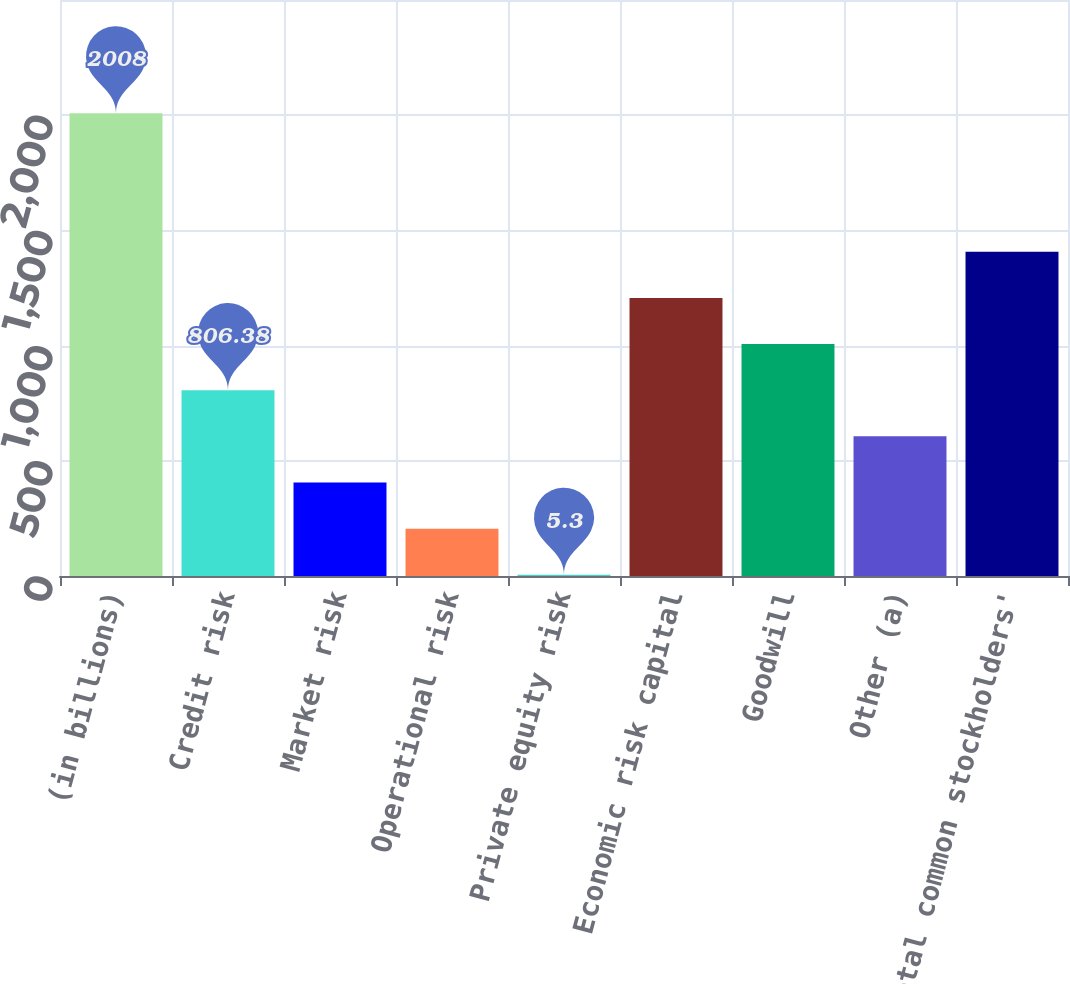Convert chart to OTSL. <chart><loc_0><loc_0><loc_500><loc_500><bar_chart><fcel>(in billions)<fcel>Credit risk<fcel>Market risk<fcel>Operational risk<fcel>Private equity risk<fcel>Economic risk capital<fcel>Goodwill<fcel>Other (a)<fcel>Total common stockholders'<nl><fcel>2008<fcel>806.38<fcel>405.84<fcel>205.57<fcel>5.3<fcel>1206.92<fcel>1006.65<fcel>606.11<fcel>1407.19<nl></chart> 